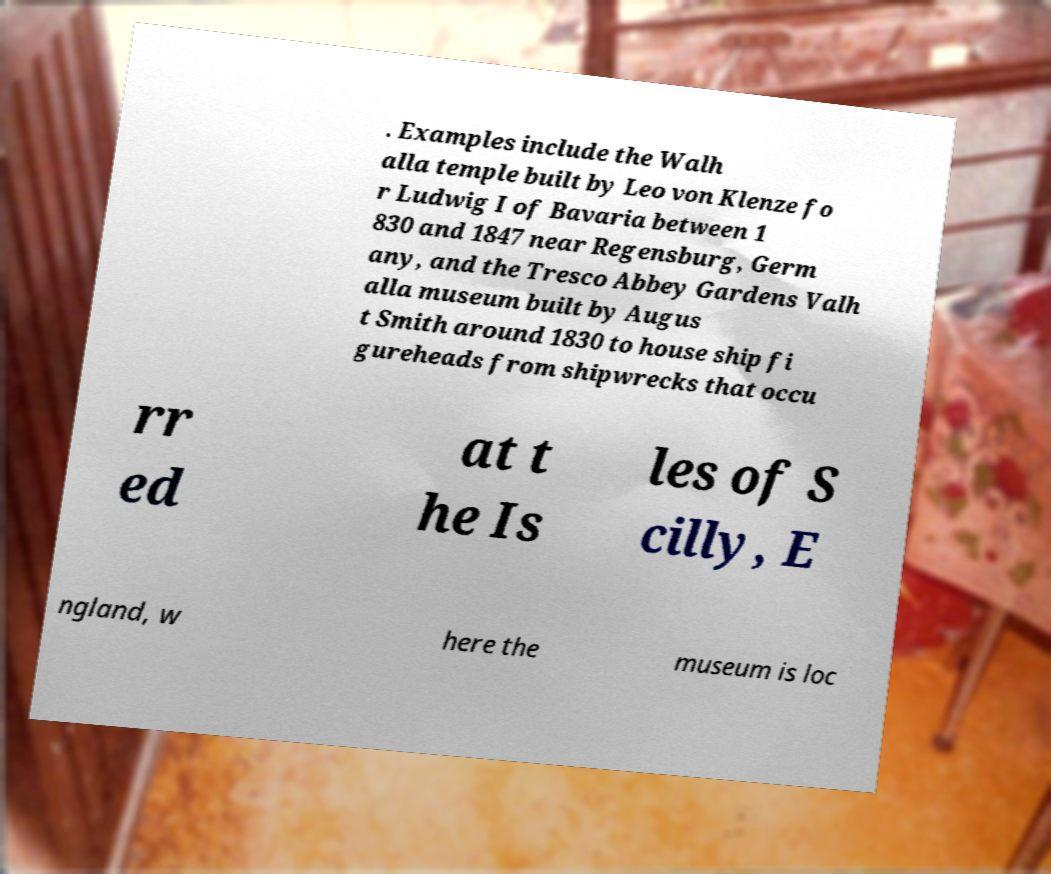What messages or text are displayed in this image? I need them in a readable, typed format. . Examples include the Walh alla temple built by Leo von Klenze fo r Ludwig I of Bavaria between 1 830 and 1847 near Regensburg, Germ any, and the Tresco Abbey Gardens Valh alla museum built by Augus t Smith around 1830 to house ship fi gureheads from shipwrecks that occu rr ed at t he Is les of S cilly, E ngland, w here the museum is loc 